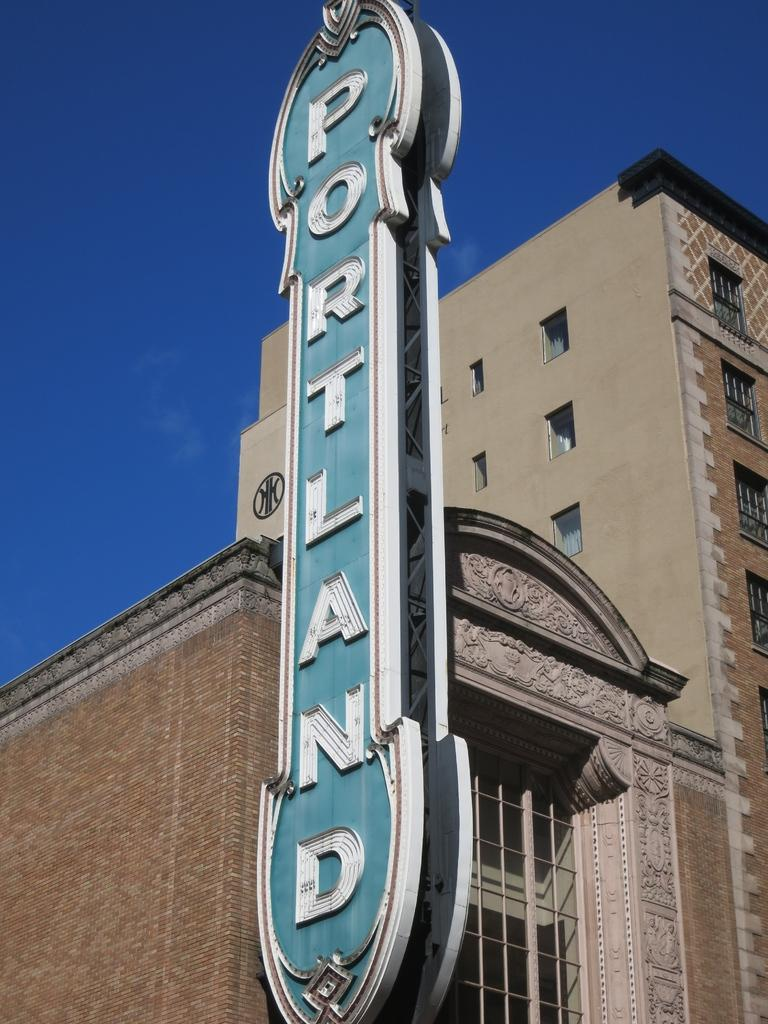What type of structure is present in the image? There is a building in the image. What feature can be seen on the building? The building has windows. Is there any signage on the building? Yes, there is a name board on the building. What can be seen in the background of the image? The sky is visible in the background of the image. How many toes can be seen on the building in the image? There are no toes present on the building in the image. Can you describe the jumping activity taking place in the image? There is no jumping activity depicted in the image. 